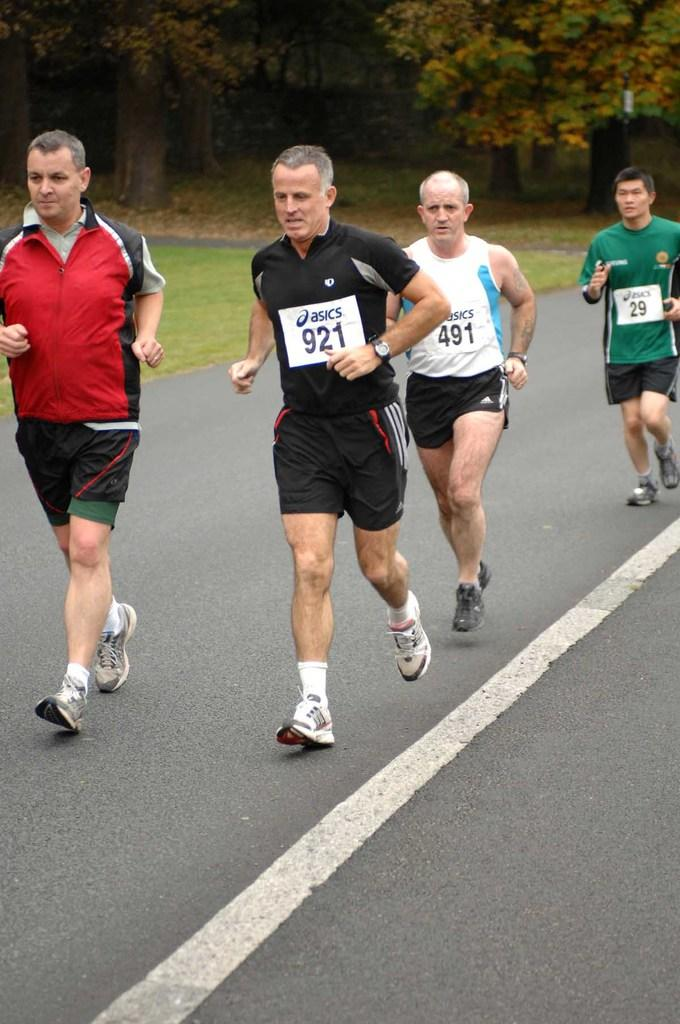What are the people in the image doing? The people in the image are jogging. Where are the people jogging? The people are on the road. What are the people wearing while jogging? The people are wearing different color dresses. What can be seen in the background of the image? There are many trees in the background of the image. Can you see any clouds or an ocean in the image? No, there are no clouds or ocean visible in the image. Is there a letter being delivered by one of the joggers in the image? There is no letter or delivery activity depicted in the image. 